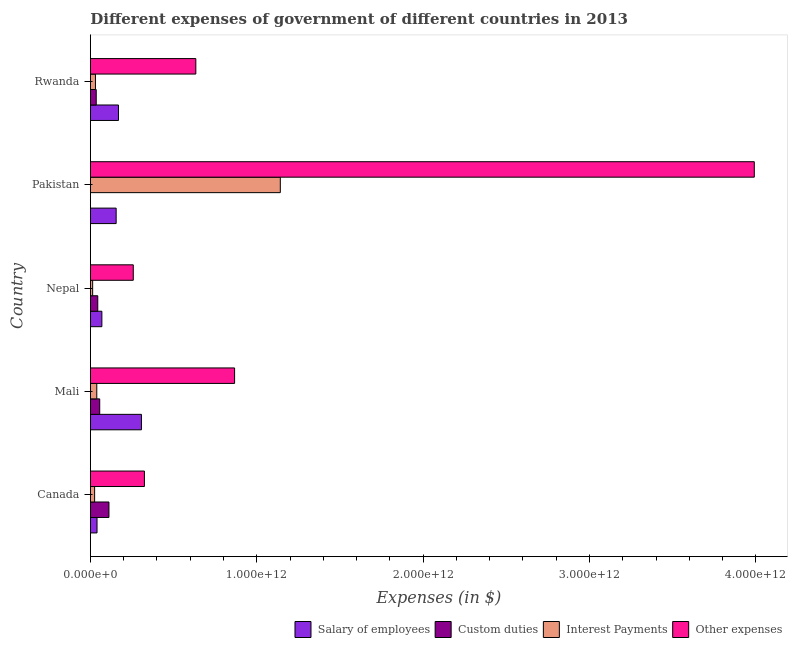Are the number of bars per tick equal to the number of legend labels?
Your response must be concise. Yes. What is the amount spent on interest payments in Nepal?
Provide a short and direct response. 1.38e+1. Across all countries, what is the maximum amount spent on other expenses?
Give a very brief answer. 3.99e+12. Across all countries, what is the minimum amount spent on custom duties?
Offer a terse response. 5.02e+06. In which country was the amount spent on custom duties maximum?
Ensure brevity in your answer.  Canada. In which country was the amount spent on other expenses minimum?
Provide a succinct answer. Nepal. What is the total amount spent on salary of employees in the graph?
Ensure brevity in your answer.  7.40e+11. What is the difference between the amount spent on interest payments in Canada and that in Mali?
Ensure brevity in your answer.  -1.30e+1. What is the difference between the amount spent on interest payments in Pakistan and the amount spent on other expenses in Canada?
Provide a short and direct response. 8.17e+11. What is the average amount spent on interest payments per country?
Ensure brevity in your answer.  2.50e+11. What is the difference between the amount spent on other expenses and amount spent on salary of employees in Canada?
Keep it short and to the point. 2.85e+11. What is the ratio of the amount spent on other expenses in Canada to that in Rwanda?
Keep it short and to the point. 0.51. Is the difference between the amount spent on custom duties in Canada and Pakistan greater than the difference between the amount spent on other expenses in Canada and Pakistan?
Your answer should be very brief. Yes. What is the difference between the highest and the second highest amount spent on custom duties?
Ensure brevity in your answer.  5.55e+1. What is the difference between the highest and the lowest amount spent on interest payments?
Your response must be concise. 1.13e+12. What does the 3rd bar from the top in Mali represents?
Give a very brief answer. Custom duties. What does the 3rd bar from the bottom in Mali represents?
Provide a succinct answer. Interest Payments. Is it the case that in every country, the sum of the amount spent on salary of employees and amount spent on custom duties is greater than the amount spent on interest payments?
Make the answer very short. No. What is the difference between two consecutive major ticks on the X-axis?
Make the answer very short. 1.00e+12. Does the graph contain any zero values?
Offer a very short reply. No. Does the graph contain grids?
Provide a succinct answer. No. Where does the legend appear in the graph?
Make the answer very short. Bottom right. How are the legend labels stacked?
Ensure brevity in your answer.  Horizontal. What is the title of the graph?
Your answer should be very brief. Different expenses of government of different countries in 2013. What is the label or title of the X-axis?
Make the answer very short. Expenses (in $). What is the Expenses (in $) in Salary of employees in Canada?
Give a very brief answer. 4.01e+1. What is the Expenses (in $) of Custom duties in Canada?
Give a very brief answer. 1.12e+11. What is the Expenses (in $) in Interest Payments in Canada?
Ensure brevity in your answer.  2.56e+1. What is the Expenses (in $) of Other expenses in Canada?
Your answer should be very brief. 3.25e+11. What is the Expenses (in $) of Salary of employees in Mali?
Make the answer very short. 3.07e+11. What is the Expenses (in $) of Custom duties in Mali?
Your response must be concise. 5.62e+1. What is the Expenses (in $) in Interest Payments in Mali?
Your answer should be compact. 3.86e+1. What is the Expenses (in $) in Other expenses in Mali?
Give a very brief answer. 8.67e+11. What is the Expenses (in $) in Salary of employees in Nepal?
Provide a succinct answer. 6.91e+1. What is the Expenses (in $) in Custom duties in Nepal?
Offer a terse response. 4.45e+1. What is the Expenses (in $) of Interest Payments in Nepal?
Keep it short and to the point. 1.38e+1. What is the Expenses (in $) in Other expenses in Nepal?
Provide a succinct answer. 2.58e+11. What is the Expenses (in $) of Salary of employees in Pakistan?
Offer a very short reply. 1.55e+11. What is the Expenses (in $) of Custom duties in Pakistan?
Offer a terse response. 5.02e+06. What is the Expenses (in $) in Interest Payments in Pakistan?
Make the answer very short. 1.14e+12. What is the Expenses (in $) of Other expenses in Pakistan?
Make the answer very short. 3.99e+12. What is the Expenses (in $) in Salary of employees in Rwanda?
Offer a terse response. 1.69e+11. What is the Expenses (in $) of Custom duties in Rwanda?
Offer a very short reply. 3.53e+1. What is the Expenses (in $) in Interest Payments in Rwanda?
Provide a short and direct response. 3.07e+1. What is the Expenses (in $) of Other expenses in Rwanda?
Ensure brevity in your answer.  6.34e+11. Across all countries, what is the maximum Expenses (in $) of Salary of employees?
Offer a terse response. 3.07e+11. Across all countries, what is the maximum Expenses (in $) in Custom duties?
Provide a short and direct response. 1.12e+11. Across all countries, what is the maximum Expenses (in $) in Interest Payments?
Ensure brevity in your answer.  1.14e+12. Across all countries, what is the maximum Expenses (in $) of Other expenses?
Provide a short and direct response. 3.99e+12. Across all countries, what is the minimum Expenses (in $) in Salary of employees?
Keep it short and to the point. 4.01e+1. Across all countries, what is the minimum Expenses (in $) of Custom duties?
Offer a terse response. 5.02e+06. Across all countries, what is the minimum Expenses (in $) of Interest Payments?
Offer a very short reply. 1.38e+1. Across all countries, what is the minimum Expenses (in $) in Other expenses?
Your answer should be compact. 2.58e+11. What is the total Expenses (in $) in Salary of employees in the graph?
Make the answer very short. 7.40e+11. What is the total Expenses (in $) in Custom duties in the graph?
Offer a very short reply. 2.48e+11. What is the total Expenses (in $) of Interest Payments in the graph?
Your response must be concise. 1.25e+12. What is the total Expenses (in $) of Other expenses in the graph?
Make the answer very short. 6.07e+12. What is the difference between the Expenses (in $) in Salary of employees in Canada and that in Mali?
Make the answer very short. -2.67e+11. What is the difference between the Expenses (in $) of Custom duties in Canada and that in Mali?
Offer a very short reply. 5.55e+1. What is the difference between the Expenses (in $) in Interest Payments in Canada and that in Mali?
Ensure brevity in your answer.  -1.30e+1. What is the difference between the Expenses (in $) of Other expenses in Canada and that in Mali?
Keep it short and to the point. -5.42e+11. What is the difference between the Expenses (in $) of Salary of employees in Canada and that in Nepal?
Provide a succinct answer. -2.91e+1. What is the difference between the Expenses (in $) of Custom duties in Canada and that in Nepal?
Provide a succinct answer. 6.73e+1. What is the difference between the Expenses (in $) of Interest Payments in Canada and that in Nepal?
Provide a short and direct response. 1.18e+1. What is the difference between the Expenses (in $) in Other expenses in Canada and that in Nepal?
Make the answer very short. 6.70e+1. What is the difference between the Expenses (in $) of Salary of employees in Canada and that in Pakistan?
Offer a very short reply. -1.15e+11. What is the difference between the Expenses (in $) in Custom duties in Canada and that in Pakistan?
Make the answer very short. 1.12e+11. What is the difference between the Expenses (in $) in Interest Payments in Canada and that in Pakistan?
Ensure brevity in your answer.  -1.12e+12. What is the difference between the Expenses (in $) in Other expenses in Canada and that in Pakistan?
Ensure brevity in your answer.  -3.67e+12. What is the difference between the Expenses (in $) in Salary of employees in Canada and that in Rwanda?
Keep it short and to the point. -1.29e+11. What is the difference between the Expenses (in $) of Custom duties in Canada and that in Rwanda?
Offer a terse response. 7.65e+1. What is the difference between the Expenses (in $) in Interest Payments in Canada and that in Rwanda?
Your answer should be compact. -5.10e+09. What is the difference between the Expenses (in $) of Other expenses in Canada and that in Rwanda?
Your answer should be compact. -3.09e+11. What is the difference between the Expenses (in $) of Salary of employees in Mali and that in Nepal?
Give a very brief answer. 2.38e+11. What is the difference between the Expenses (in $) of Custom duties in Mali and that in Nepal?
Your answer should be compact. 1.17e+1. What is the difference between the Expenses (in $) in Interest Payments in Mali and that in Nepal?
Ensure brevity in your answer.  2.47e+1. What is the difference between the Expenses (in $) of Other expenses in Mali and that in Nepal?
Your response must be concise. 6.09e+11. What is the difference between the Expenses (in $) in Salary of employees in Mali and that in Pakistan?
Offer a terse response. 1.52e+11. What is the difference between the Expenses (in $) of Custom duties in Mali and that in Pakistan?
Provide a succinct answer. 5.62e+1. What is the difference between the Expenses (in $) in Interest Payments in Mali and that in Pakistan?
Your answer should be compact. -1.10e+12. What is the difference between the Expenses (in $) of Other expenses in Mali and that in Pakistan?
Make the answer very short. -3.12e+12. What is the difference between the Expenses (in $) in Salary of employees in Mali and that in Rwanda?
Ensure brevity in your answer.  1.38e+11. What is the difference between the Expenses (in $) of Custom duties in Mali and that in Rwanda?
Your answer should be compact. 2.09e+1. What is the difference between the Expenses (in $) in Interest Payments in Mali and that in Rwanda?
Make the answer very short. 7.86e+09. What is the difference between the Expenses (in $) in Other expenses in Mali and that in Rwanda?
Offer a terse response. 2.33e+11. What is the difference between the Expenses (in $) of Salary of employees in Nepal and that in Pakistan?
Your answer should be very brief. -8.59e+1. What is the difference between the Expenses (in $) in Custom duties in Nepal and that in Pakistan?
Your response must be concise. 4.45e+1. What is the difference between the Expenses (in $) in Interest Payments in Nepal and that in Pakistan?
Offer a very short reply. -1.13e+12. What is the difference between the Expenses (in $) in Other expenses in Nepal and that in Pakistan?
Offer a terse response. -3.73e+12. What is the difference between the Expenses (in $) of Salary of employees in Nepal and that in Rwanda?
Offer a very short reply. -9.98e+1. What is the difference between the Expenses (in $) of Custom duties in Nepal and that in Rwanda?
Offer a terse response. 9.20e+09. What is the difference between the Expenses (in $) of Interest Payments in Nepal and that in Rwanda?
Provide a short and direct response. -1.69e+1. What is the difference between the Expenses (in $) of Other expenses in Nepal and that in Rwanda?
Make the answer very short. -3.76e+11. What is the difference between the Expenses (in $) in Salary of employees in Pakistan and that in Rwanda?
Make the answer very short. -1.39e+1. What is the difference between the Expenses (in $) in Custom duties in Pakistan and that in Rwanda?
Offer a very short reply. -3.53e+1. What is the difference between the Expenses (in $) in Interest Payments in Pakistan and that in Rwanda?
Your answer should be very brief. 1.11e+12. What is the difference between the Expenses (in $) of Other expenses in Pakistan and that in Rwanda?
Offer a terse response. 3.36e+12. What is the difference between the Expenses (in $) of Salary of employees in Canada and the Expenses (in $) of Custom duties in Mali?
Offer a very short reply. -1.62e+1. What is the difference between the Expenses (in $) of Salary of employees in Canada and the Expenses (in $) of Interest Payments in Mali?
Offer a very short reply. 1.50e+09. What is the difference between the Expenses (in $) in Salary of employees in Canada and the Expenses (in $) in Other expenses in Mali?
Your response must be concise. -8.27e+11. What is the difference between the Expenses (in $) of Custom duties in Canada and the Expenses (in $) of Interest Payments in Mali?
Offer a very short reply. 7.32e+1. What is the difference between the Expenses (in $) in Custom duties in Canada and the Expenses (in $) in Other expenses in Mali?
Make the answer very short. -7.55e+11. What is the difference between the Expenses (in $) in Interest Payments in Canada and the Expenses (in $) in Other expenses in Mali?
Provide a short and direct response. -8.41e+11. What is the difference between the Expenses (in $) in Salary of employees in Canada and the Expenses (in $) in Custom duties in Nepal?
Give a very brief answer. -4.44e+09. What is the difference between the Expenses (in $) of Salary of employees in Canada and the Expenses (in $) of Interest Payments in Nepal?
Ensure brevity in your answer.  2.63e+1. What is the difference between the Expenses (in $) in Salary of employees in Canada and the Expenses (in $) in Other expenses in Nepal?
Provide a short and direct response. -2.18e+11. What is the difference between the Expenses (in $) of Custom duties in Canada and the Expenses (in $) of Interest Payments in Nepal?
Make the answer very short. 9.80e+1. What is the difference between the Expenses (in $) of Custom duties in Canada and the Expenses (in $) of Other expenses in Nepal?
Make the answer very short. -1.46e+11. What is the difference between the Expenses (in $) of Interest Payments in Canada and the Expenses (in $) of Other expenses in Nepal?
Offer a terse response. -2.32e+11. What is the difference between the Expenses (in $) in Salary of employees in Canada and the Expenses (in $) in Custom duties in Pakistan?
Your response must be concise. 4.01e+1. What is the difference between the Expenses (in $) in Salary of employees in Canada and the Expenses (in $) in Interest Payments in Pakistan?
Offer a terse response. -1.10e+12. What is the difference between the Expenses (in $) in Salary of employees in Canada and the Expenses (in $) in Other expenses in Pakistan?
Ensure brevity in your answer.  -3.95e+12. What is the difference between the Expenses (in $) of Custom duties in Canada and the Expenses (in $) of Interest Payments in Pakistan?
Your answer should be very brief. -1.03e+12. What is the difference between the Expenses (in $) of Custom duties in Canada and the Expenses (in $) of Other expenses in Pakistan?
Provide a short and direct response. -3.88e+12. What is the difference between the Expenses (in $) of Interest Payments in Canada and the Expenses (in $) of Other expenses in Pakistan?
Your response must be concise. -3.97e+12. What is the difference between the Expenses (in $) in Salary of employees in Canada and the Expenses (in $) in Custom duties in Rwanda?
Make the answer very short. 4.76e+09. What is the difference between the Expenses (in $) of Salary of employees in Canada and the Expenses (in $) of Interest Payments in Rwanda?
Make the answer very short. 9.36e+09. What is the difference between the Expenses (in $) of Salary of employees in Canada and the Expenses (in $) of Other expenses in Rwanda?
Ensure brevity in your answer.  -5.94e+11. What is the difference between the Expenses (in $) of Custom duties in Canada and the Expenses (in $) of Interest Payments in Rwanda?
Offer a very short reply. 8.11e+1. What is the difference between the Expenses (in $) in Custom duties in Canada and the Expenses (in $) in Other expenses in Rwanda?
Provide a succinct answer. -5.22e+11. What is the difference between the Expenses (in $) in Interest Payments in Canada and the Expenses (in $) in Other expenses in Rwanda?
Your answer should be compact. -6.08e+11. What is the difference between the Expenses (in $) of Salary of employees in Mali and the Expenses (in $) of Custom duties in Nepal?
Offer a terse response. 2.63e+11. What is the difference between the Expenses (in $) in Salary of employees in Mali and the Expenses (in $) in Interest Payments in Nepal?
Give a very brief answer. 2.93e+11. What is the difference between the Expenses (in $) in Salary of employees in Mali and the Expenses (in $) in Other expenses in Nepal?
Provide a short and direct response. 4.91e+1. What is the difference between the Expenses (in $) of Custom duties in Mali and the Expenses (in $) of Interest Payments in Nepal?
Your response must be concise. 4.24e+1. What is the difference between the Expenses (in $) in Custom duties in Mali and the Expenses (in $) in Other expenses in Nepal?
Offer a very short reply. -2.02e+11. What is the difference between the Expenses (in $) of Interest Payments in Mali and the Expenses (in $) of Other expenses in Nepal?
Your answer should be very brief. -2.19e+11. What is the difference between the Expenses (in $) of Salary of employees in Mali and the Expenses (in $) of Custom duties in Pakistan?
Your answer should be very brief. 3.07e+11. What is the difference between the Expenses (in $) in Salary of employees in Mali and the Expenses (in $) in Interest Payments in Pakistan?
Offer a terse response. -8.35e+11. What is the difference between the Expenses (in $) of Salary of employees in Mali and the Expenses (in $) of Other expenses in Pakistan?
Offer a terse response. -3.68e+12. What is the difference between the Expenses (in $) of Custom duties in Mali and the Expenses (in $) of Interest Payments in Pakistan?
Provide a succinct answer. -1.09e+12. What is the difference between the Expenses (in $) of Custom duties in Mali and the Expenses (in $) of Other expenses in Pakistan?
Provide a succinct answer. -3.93e+12. What is the difference between the Expenses (in $) of Interest Payments in Mali and the Expenses (in $) of Other expenses in Pakistan?
Keep it short and to the point. -3.95e+12. What is the difference between the Expenses (in $) in Salary of employees in Mali and the Expenses (in $) in Custom duties in Rwanda?
Offer a terse response. 2.72e+11. What is the difference between the Expenses (in $) in Salary of employees in Mali and the Expenses (in $) in Interest Payments in Rwanda?
Offer a very short reply. 2.76e+11. What is the difference between the Expenses (in $) in Salary of employees in Mali and the Expenses (in $) in Other expenses in Rwanda?
Provide a succinct answer. -3.27e+11. What is the difference between the Expenses (in $) in Custom duties in Mali and the Expenses (in $) in Interest Payments in Rwanda?
Your response must be concise. 2.55e+1. What is the difference between the Expenses (in $) of Custom duties in Mali and the Expenses (in $) of Other expenses in Rwanda?
Give a very brief answer. -5.78e+11. What is the difference between the Expenses (in $) of Interest Payments in Mali and the Expenses (in $) of Other expenses in Rwanda?
Give a very brief answer. -5.95e+11. What is the difference between the Expenses (in $) of Salary of employees in Nepal and the Expenses (in $) of Custom duties in Pakistan?
Give a very brief answer. 6.91e+1. What is the difference between the Expenses (in $) of Salary of employees in Nepal and the Expenses (in $) of Interest Payments in Pakistan?
Your answer should be compact. -1.07e+12. What is the difference between the Expenses (in $) in Salary of employees in Nepal and the Expenses (in $) in Other expenses in Pakistan?
Make the answer very short. -3.92e+12. What is the difference between the Expenses (in $) of Custom duties in Nepal and the Expenses (in $) of Interest Payments in Pakistan?
Provide a short and direct response. -1.10e+12. What is the difference between the Expenses (in $) in Custom duties in Nepal and the Expenses (in $) in Other expenses in Pakistan?
Keep it short and to the point. -3.95e+12. What is the difference between the Expenses (in $) of Interest Payments in Nepal and the Expenses (in $) of Other expenses in Pakistan?
Make the answer very short. -3.98e+12. What is the difference between the Expenses (in $) of Salary of employees in Nepal and the Expenses (in $) of Custom duties in Rwanda?
Provide a succinct answer. 3.38e+1. What is the difference between the Expenses (in $) of Salary of employees in Nepal and the Expenses (in $) of Interest Payments in Rwanda?
Offer a terse response. 3.84e+1. What is the difference between the Expenses (in $) of Salary of employees in Nepal and the Expenses (in $) of Other expenses in Rwanda?
Ensure brevity in your answer.  -5.65e+11. What is the difference between the Expenses (in $) in Custom duties in Nepal and the Expenses (in $) in Interest Payments in Rwanda?
Offer a very short reply. 1.38e+1. What is the difference between the Expenses (in $) of Custom duties in Nepal and the Expenses (in $) of Other expenses in Rwanda?
Your response must be concise. -5.89e+11. What is the difference between the Expenses (in $) of Interest Payments in Nepal and the Expenses (in $) of Other expenses in Rwanda?
Provide a succinct answer. -6.20e+11. What is the difference between the Expenses (in $) in Salary of employees in Pakistan and the Expenses (in $) in Custom duties in Rwanda?
Your answer should be very brief. 1.20e+11. What is the difference between the Expenses (in $) of Salary of employees in Pakistan and the Expenses (in $) of Interest Payments in Rwanda?
Ensure brevity in your answer.  1.24e+11. What is the difference between the Expenses (in $) of Salary of employees in Pakistan and the Expenses (in $) of Other expenses in Rwanda?
Your answer should be very brief. -4.79e+11. What is the difference between the Expenses (in $) of Custom duties in Pakistan and the Expenses (in $) of Interest Payments in Rwanda?
Give a very brief answer. -3.07e+1. What is the difference between the Expenses (in $) of Custom duties in Pakistan and the Expenses (in $) of Other expenses in Rwanda?
Ensure brevity in your answer.  -6.34e+11. What is the difference between the Expenses (in $) of Interest Payments in Pakistan and the Expenses (in $) of Other expenses in Rwanda?
Offer a terse response. 5.08e+11. What is the average Expenses (in $) in Salary of employees per country?
Give a very brief answer. 1.48e+11. What is the average Expenses (in $) of Custom duties per country?
Offer a terse response. 4.96e+1. What is the average Expenses (in $) of Interest Payments per country?
Ensure brevity in your answer.  2.50e+11. What is the average Expenses (in $) in Other expenses per country?
Your answer should be very brief. 1.21e+12. What is the difference between the Expenses (in $) in Salary of employees and Expenses (in $) in Custom duties in Canada?
Keep it short and to the point. -7.17e+1. What is the difference between the Expenses (in $) in Salary of employees and Expenses (in $) in Interest Payments in Canada?
Provide a succinct answer. 1.45e+1. What is the difference between the Expenses (in $) of Salary of employees and Expenses (in $) of Other expenses in Canada?
Ensure brevity in your answer.  -2.85e+11. What is the difference between the Expenses (in $) in Custom duties and Expenses (in $) in Interest Payments in Canada?
Your response must be concise. 8.62e+1. What is the difference between the Expenses (in $) of Custom duties and Expenses (in $) of Other expenses in Canada?
Provide a succinct answer. -2.13e+11. What is the difference between the Expenses (in $) of Interest Payments and Expenses (in $) of Other expenses in Canada?
Make the answer very short. -2.99e+11. What is the difference between the Expenses (in $) in Salary of employees and Expenses (in $) in Custom duties in Mali?
Your answer should be compact. 2.51e+11. What is the difference between the Expenses (in $) of Salary of employees and Expenses (in $) of Interest Payments in Mali?
Offer a terse response. 2.68e+11. What is the difference between the Expenses (in $) in Salary of employees and Expenses (in $) in Other expenses in Mali?
Provide a short and direct response. -5.60e+11. What is the difference between the Expenses (in $) in Custom duties and Expenses (in $) in Interest Payments in Mali?
Offer a very short reply. 1.77e+1. What is the difference between the Expenses (in $) of Custom duties and Expenses (in $) of Other expenses in Mali?
Your answer should be compact. -8.11e+11. What is the difference between the Expenses (in $) of Interest Payments and Expenses (in $) of Other expenses in Mali?
Keep it short and to the point. -8.28e+11. What is the difference between the Expenses (in $) of Salary of employees and Expenses (in $) of Custom duties in Nepal?
Give a very brief answer. 2.46e+1. What is the difference between the Expenses (in $) in Salary of employees and Expenses (in $) in Interest Payments in Nepal?
Your answer should be compact. 5.53e+1. What is the difference between the Expenses (in $) in Salary of employees and Expenses (in $) in Other expenses in Nepal?
Ensure brevity in your answer.  -1.89e+11. What is the difference between the Expenses (in $) of Custom duties and Expenses (in $) of Interest Payments in Nepal?
Your answer should be very brief. 3.07e+1. What is the difference between the Expenses (in $) of Custom duties and Expenses (in $) of Other expenses in Nepal?
Your response must be concise. -2.13e+11. What is the difference between the Expenses (in $) in Interest Payments and Expenses (in $) in Other expenses in Nepal?
Provide a succinct answer. -2.44e+11. What is the difference between the Expenses (in $) in Salary of employees and Expenses (in $) in Custom duties in Pakistan?
Give a very brief answer. 1.55e+11. What is the difference between the Expenses (in $) in Salary of employees and Expenses (in $) in Interest Payments in Pakistan?
Make the answer very short. -9.87e+11. What is the difference between the Expenses (in $) of Salary of employees and Expenses (in $) of Other expenses in Pakistan?
Keep it short and to the point. -3.84e+12. What is the difference between the Expenses (in $) in Custom duties and Expenses (in $) in Interest Payments in Pakistan?
Provide a succinct answer. -1.14e+12. What is the difference between the Expenses (in $) in Custom duties and Expenses (in $) in Other expenses in Pakistan?
Your answer should be very brief. -3.99e+12. What is the difference between the Expenses (in $) in Interest Payments and Expenses (in $) in Other expenses in Pakistan?
Offer a terse response. -2.85e+12. What is the difference between the Expenses (in $) of Salary of employees and Expenses (in $) of Custom duties in Rwanda?
Provide a succinct answer. 1.34e+11. What is the difference between the Expenses (in $) of Salary of employees and Expenses (in $) of Interest Payments in Rwanda?
Provide a succinct answer. 1.38e+11. What is the difference between the Expenses (in $) in Salary of employees and Expenses (in $) in Other expenses in Rwanda?
Offer a terse response. -4.65e+11. What is the difference between the Expenses (in $) of Custom duties and Expenses (in $) of Interest Payments in Rwanda?
Provide a succinct answer. 4.60e+09. What is the difference between the Expenses (in $) in Custom duties and Expenses (in $) in Other expenses in Rwanda?
Keep it short and to the point. -5.99e+11. What is the difference between the Expenses (in $) in Interest Payments and Expenses (in $) in Other expenses in Rwanda?
Offer a terse response. -6.03e+11. What is the ratio of the Expenses (in $) of Salary of employees in Canada to that in Mali?
Offer a terse response. 0.13. What is the ratio of the Expenses (in $) in Custom duties in Canada to that in Mali?
Ensure brevity in your answer.  1.99. What is the ratio of the Expenses (in $) in Interest Payments in Canada to that in Mali?
Provide a succinct answer. 0.66. What is the ratio of the Expenses (in $) in Other expenses in Canada to that in Mali?
Give a very brief answer. 0.37. What is the ratio of the Expenses (in $) of Salary of employees in Canada to that in Nepal?
Give a very brief answer. 0.58. What is the ratio of the Expenses (in $) of Custom duties in Canada to that in Nepal?
Your answer should be very brief. 2.51. What is the ratio of the Expenses (in $) of Interest Payments in Canada to that in Nepal?
Give a very brief answer. 1.85. What is the ratio of the Expenses (in $) of Other expenses in Canada to that in Nepal?
Make the answer very short. 1.26. What is the ratio of the Expenses (in $) in Salary of employees in Canada to that in Pakistan?
Your answer should be very brief. 0.26. What is the ratio of the Expenses (in $) of Custom duties in Canada to that in Pakistan?
Your answer should be very brief. 2.23e+04. What is the ratio of the Expenses (in $) in Interest Payments in Canada to that in Pakistan?
Your answer should be compact. 0.02. What is the ratio of the Expenses (in $) in Other expenses in Canada to that in Pakistan?
Ensure brevity in your answer.  0.08. What is the ratio of the Expenses (in $) in Salary of employees in Canada to that in Rwanda?
Your answer should be compact. 0.24. What is the ratio of the Expenses (in $) in Custom duties in Canada to that in Rwanda?
Your answer should be compact. 3.17. What is the ratio of the Expenses (in $) in Interest Payments in Canada to that in Rwanda?
Provide a succinct answer. 0.83. What is the ratio of the Expenses (in $) of Other expenses in Canada to that in Rwanda?
Your answer should be very brief. 0.51. What is the ratio of the Expenses (in $) of Salary of employees in Mali to that in Nepal?
Ensure brevity in your answer.  4.44. What is the ratio of the Expenses (in $) of Custom duties in Mali to that in Nepal?
Keep it short and to the point. 1.26. What is the ratio of the Expenses (in $) in Interest Payments in Mali to that in Nepal?
Your answer should be very brief. 2.79. What is the ratio of the Expenses (in $) of Other expenses in Mali to that in Nepal?
Keep it short and to the point. 3.36. What is the ratio of the Expenses (in $) in Salary of employees in Mali to that in Pakistan?
Your answer should be very brief. 1.98. What is the ratio of the Expenses (in $) of Custom duties in Mali to that in Pakistan?
Offer a very short reply. 1.12e+04. What is the ratio of the Expenses (in $) of Interest Payments in Mali to that in Pakistan?
Keep it short and to the point. 0.03. What is the ratio of the Expenses (in $) in Other expenses in Mali to that in Pakistan?
Offer a terse response. 0.22. What is the ratio of the Expenses (in $) in Salary of employees in Mali to that in Rwanda?
Offer a terse response. 1.82. What is the ratio of the Expenses (in $) of Custom duties in Mali to that in Rwanda?
Make the answer very short. 1.59. What is the ratio of the Expenses (in $) of Interest Payments in Mali to that in Rwanda?
Offer a terse response. 1.26. What is the ratio of the Expenses (in $) of Other expenses in Mali to that in Rwanda?
Offer a very short reply. 1.37. What is the ratio of the Expenses (in $) in Salary of employees in Nepal to that in Pakistan?
Your answer should be compact. 0.45. What is the ratio of the Expenses (in $) of Custom duties in Nepal to that in Pakistan?
Your answer should be compact. 8863.6. What is the ratio of the Expenses (in $) of Interest Payments in Nepal to that in Pakistan?
Provide a short and direct response. 0.01. What is the ratio of the Expenses (in $) of Other expenses in Nepal to that in Pakistan?
Your response must be concise. 0.06. What is the ratio of the Expenses (in $) in Salary of employees in Nepal to that in Rwanda?
Ensure brevity in your answer.  0.41. What is the ratio of the Expenses (in $) of Custom duties in Nepal to that in Rwanda?
Provide a succinct answer. 1.26. What is the ratio of the Expenses (in $) of Interest Payments in Nepal to that in Rwanda?
Offer a terse response. 0.45. What is the ratio of the Expenses (in $) in Other expenses in Nepal to that in Rwanda?
Provide a short and direct response. 0.41. What is the ratio of the Expenses (in $) of Salary of employees in Pakistan to that in Rwanda?
Provide a succinct answer. 0.92. What is the ratio of the Expenses (in $) in Custom duties in Pakistan to that in Rwanda?
Offer a very short reply. 0. What is the ratio of the Expenses (in $) of Interest Payments in Pakistan to that in Rwanda?
Offer a very short reply. 37.19. What is the ratio of the Expenses (in $) in Other expenses in Pakistan to that in Rwanda?
Give a very brief answer. 6.3. What is the difference between the highest and the second highest Expenses (in $) of Salary of employees?
Offer a terse response. 1.38e+11. What is the difference between the highest and the second highest Expenses (in $) of Custom duties?
Give a very brief answer. 5.55e+1. What is the difference between the highest and the second highest Expenses (in $) in Interest Payments?
Your answer should be very brief. 1.10e+12. What is the difference between the highest and the second highest Expenses (in $) in Other expenses?
Provide a short and direct response. 3.12e+12. What is the difference between the highest and the lowest Expenses (in $) of Salary of employees?
Provide a succinct answer. 2.67e+11. What is the difference between the highest and the lowest Expenses (in $) of Custom duties?
Your answer should be very brief. 1.12e+11. What is the difference between the highest and the lowest Expenses (in $) in Interest Payments?
Give a very brief answer. 1.13e+12. What is the difference between the highest and the lowest Expenses (in $) in Other expenses?
Offer a terse response. 3.73e+12. 